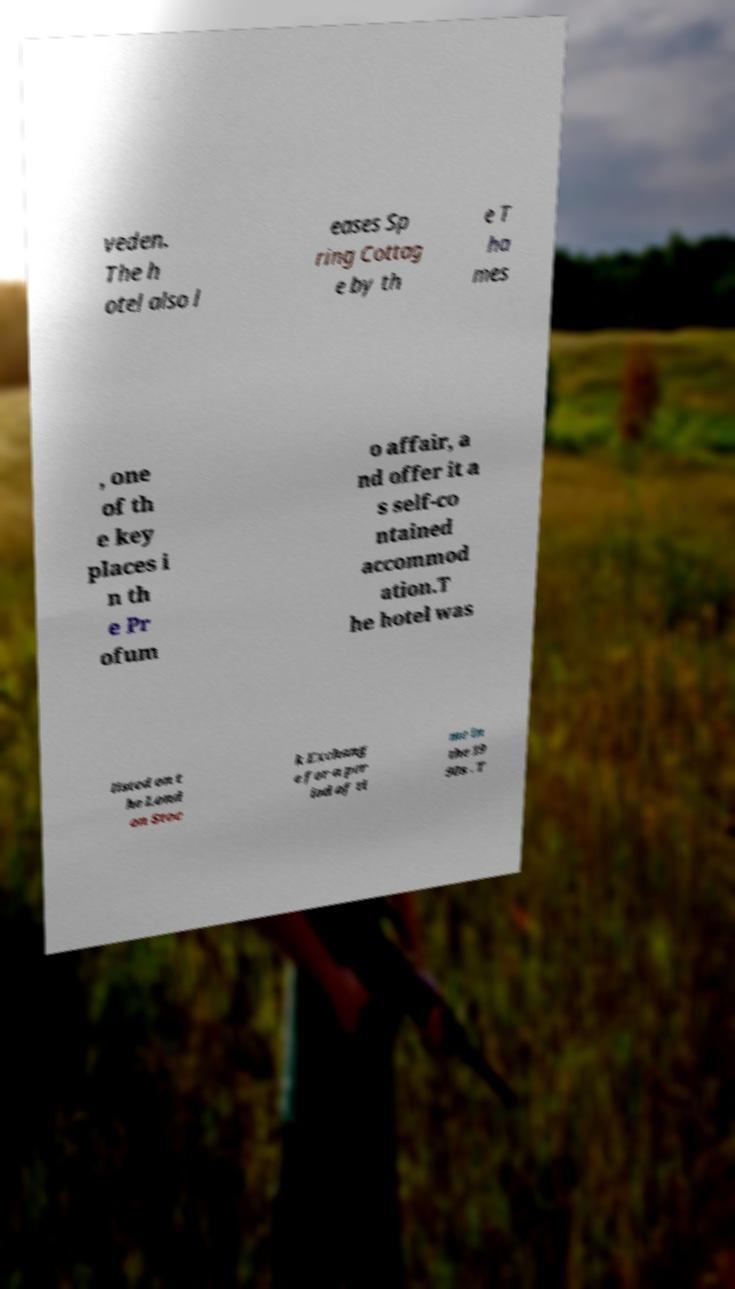Please identify and transcribe the text found in this image. veden. The h otel also l eases Sp ring Cottag e by th e T ha mes , one of th e key places i n th e Pr ofum o affair, a nd offer it a s self-co ntained accommod ation.T he hotel was listed on t he Lond on Stoc k Exchang e for a per iod of ti me in the 19 90s . T 